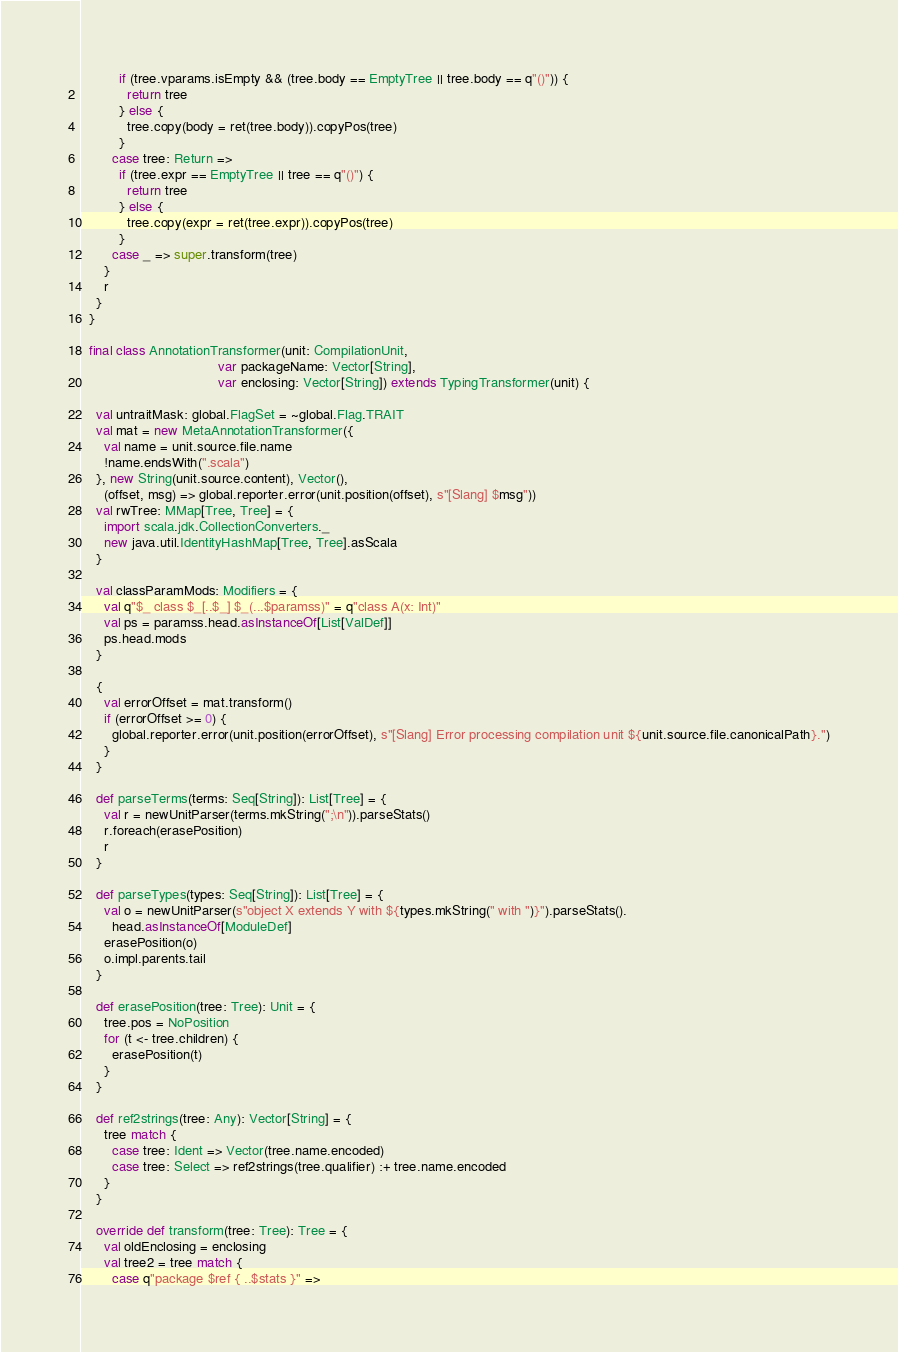<code> <loc_0><loc_0><loc_500><loc_500><_Scala_>          if (tree.vparams.isEmpty && (tree.body == EmptyTree || tree.body == q"()")) {
            return tree
          } else {
            tree.copy(body = ret(tree.body)).copyPos(tree)
          }
        case tree: Return =>
          if (tree.expr == EmptyTree || tree == q"()") {
            return tree
          } else {
            tree.copy(expr = ret(tree.expr)).copyPos(tree)
          }
        case _ => super.transform(tree)
      }
      r
    }
  }

  final class AnnotationTransformer(unit: CompilationUnit,
                                    var packageName: Vector[String],
                                    var enclosing: Vector[String]) extends TypingTransformer(unit) {

    val untraitMask: global.FlagSet = ~global.Flag.TRAIT
    val mat = new MetaAnnotationTransformer({
      val name = unit.source.file.name
      !name.endsWith(".scala")
    }, new String(unit.source.content), Vector(),
      (offset, msg) => global.reporter.error(unit.position(offset), s"[Slang] $msg"))
    val rwTree: MMap[Tree, Tree] = {
      import scala.jdk.CollectionConverters._
      new java.util.IdentityHashMap[Tree, Tree].asScala
    }

    val classParamMods: Modifiers = {
      val q"$_ class $_[..$_] $_(...$paramss)" = q"class A(x: Int)"
      val ps = paramss.head.asInstanceOf[List[ValDef]]
      ps.head.mods
    }

    {
      val errorOffset = mat.transform()
      if (errorOffset >= 0) {
        global.reporter.error(unit.position(errorOffset), s"[Slang] Error processing compilation unit ${unit.source.file.canonicalPath}.")
      }
    }

    def parseTerms(terms: Seq[String]): List[Tree] = {
      val r = newUnitParser(terms.mkString(";\n")).parseStats()
      r.foreach(erasePosition)
      r
    }

    def parseTypes(types: Seq[String]): List[Tree] = {
      val o = newUnitParser(s"object X extends Y with ${types.mkString(" with ")}").parseStats().
        head.asInstanceOf[ModuleDef]
      erasePosition(o)
      o.impl.parents.tail
    }

    def erasePosition(tree: Tree): Unit = {
      tree.pos = NoPosition
      for (t <- tree.children) {
        erasePosition(t)
      }
    }

    def ref2strings(tree: Any): Vector[String] = {
      tree match {
        case tree: Ident => Vector(tree.name.encoded)
        case tree: Select => ref2strings(tree.qualifier) :+ tree.name.encoded
      }
    }

    override def transform(tree: Tree): Tree = {
      val oldEnclosing = enclosing
      val tree2 = tree match {
        case q"package $ref { ..$stats }" =></code> 